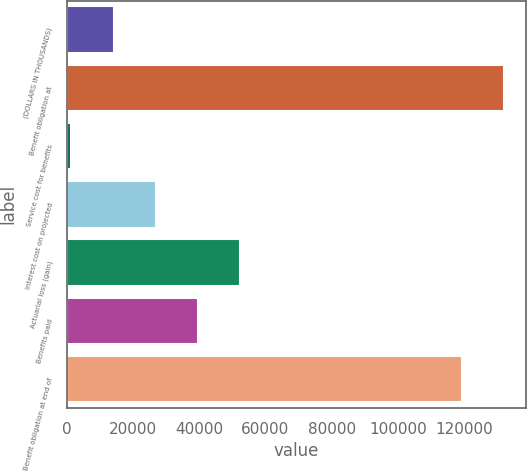Convert chart to OTSL. <chart><loc_0><loc_0><loc_500><loc_500><bar_chart><fcel>(DOLLARS IN THOUSANDS)<fcel>Benefit obligation at<fcel>Service cost for benefits<fcel>Interest cost on projected<fcel>Actuarial loss (gain)<fcel>Benefits paid<fcel>Benefit obligation at end of<nl><fcel>14093.2<fcel>132044<fcel>1357<fcel>26829.4<fcel>52301.8<fcel>39565.6<fcel>119308<nl></chart> 